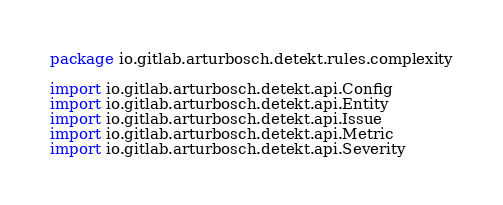<code> <loc_0><loc_0><loc_500><loc_500><_Kotlin_>package io.gitlab.arturbosch.detekt.rules.complexity

import io.gitlab.arturbosch.detekt.api.Config
import io.gitlab.arturbosch.detekt.api.Entity
import io.gitlab.arturbosch.detekt.api.Issue
import io.gitlab.arturbosch.detekt.api.Metric
import io.gitlab.arturbosch.detekt.api.Severity</code> 